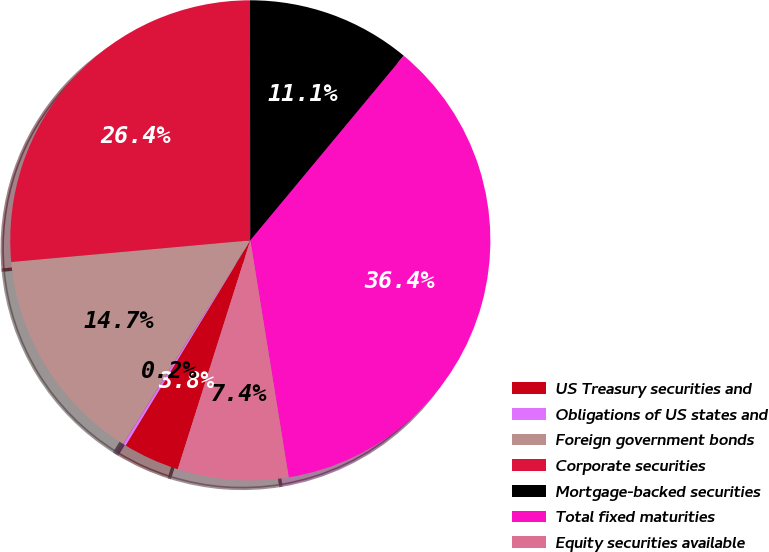Convert chart. <chart><loc_0><loc_0><loc_500><loc_500><pie_chart><fcel>US Treasury securities and<fcel>Obligations of US states and<fcel>Foreign government bonds<fcel>Corporate securities<fcel>Mortgage-backed securities<fcel>Total fixed maturities<fcel>Equity securities available<nl><fcel>3.81%<fcel>0.19%<fcel>14.68%<fcel>26.42%<fcel>11.06%<fcel>36.41%<fcel>7.44%<nl></chart> 